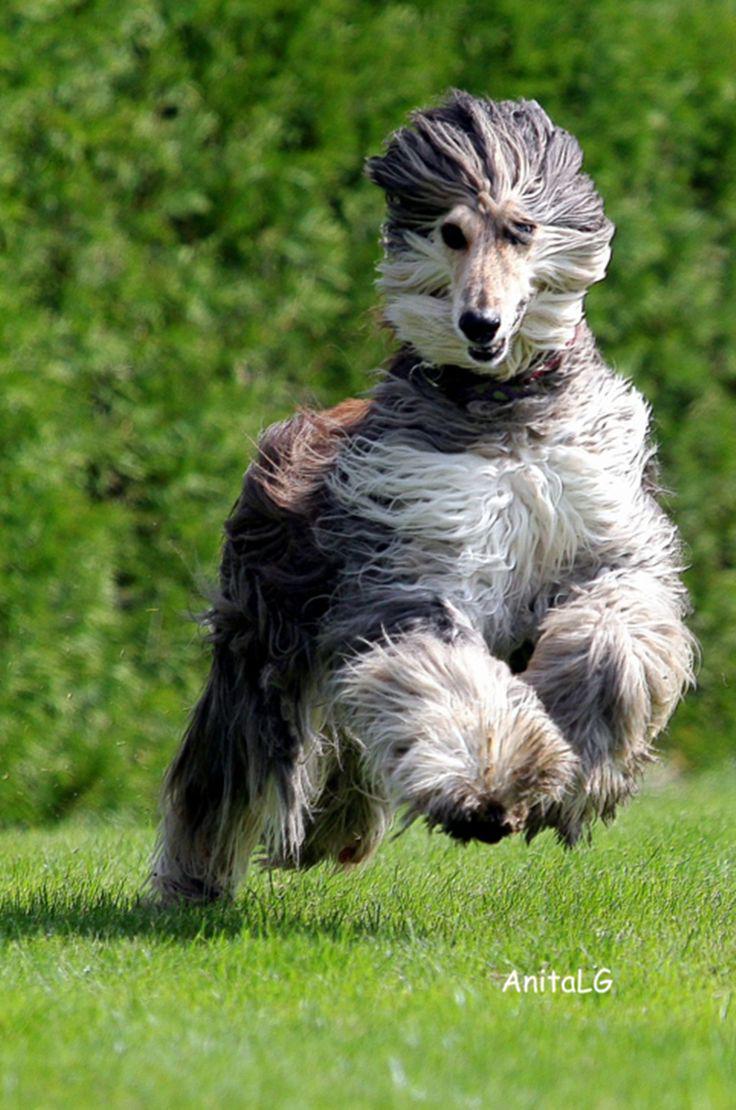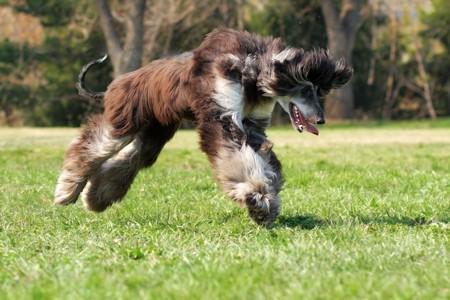The first image is the image on the left, the second image is the image on the right. Given the left and right images, does the statement "At least one image shows a dog bounding across the grass." hold true? Answer yes or no. Yes. 